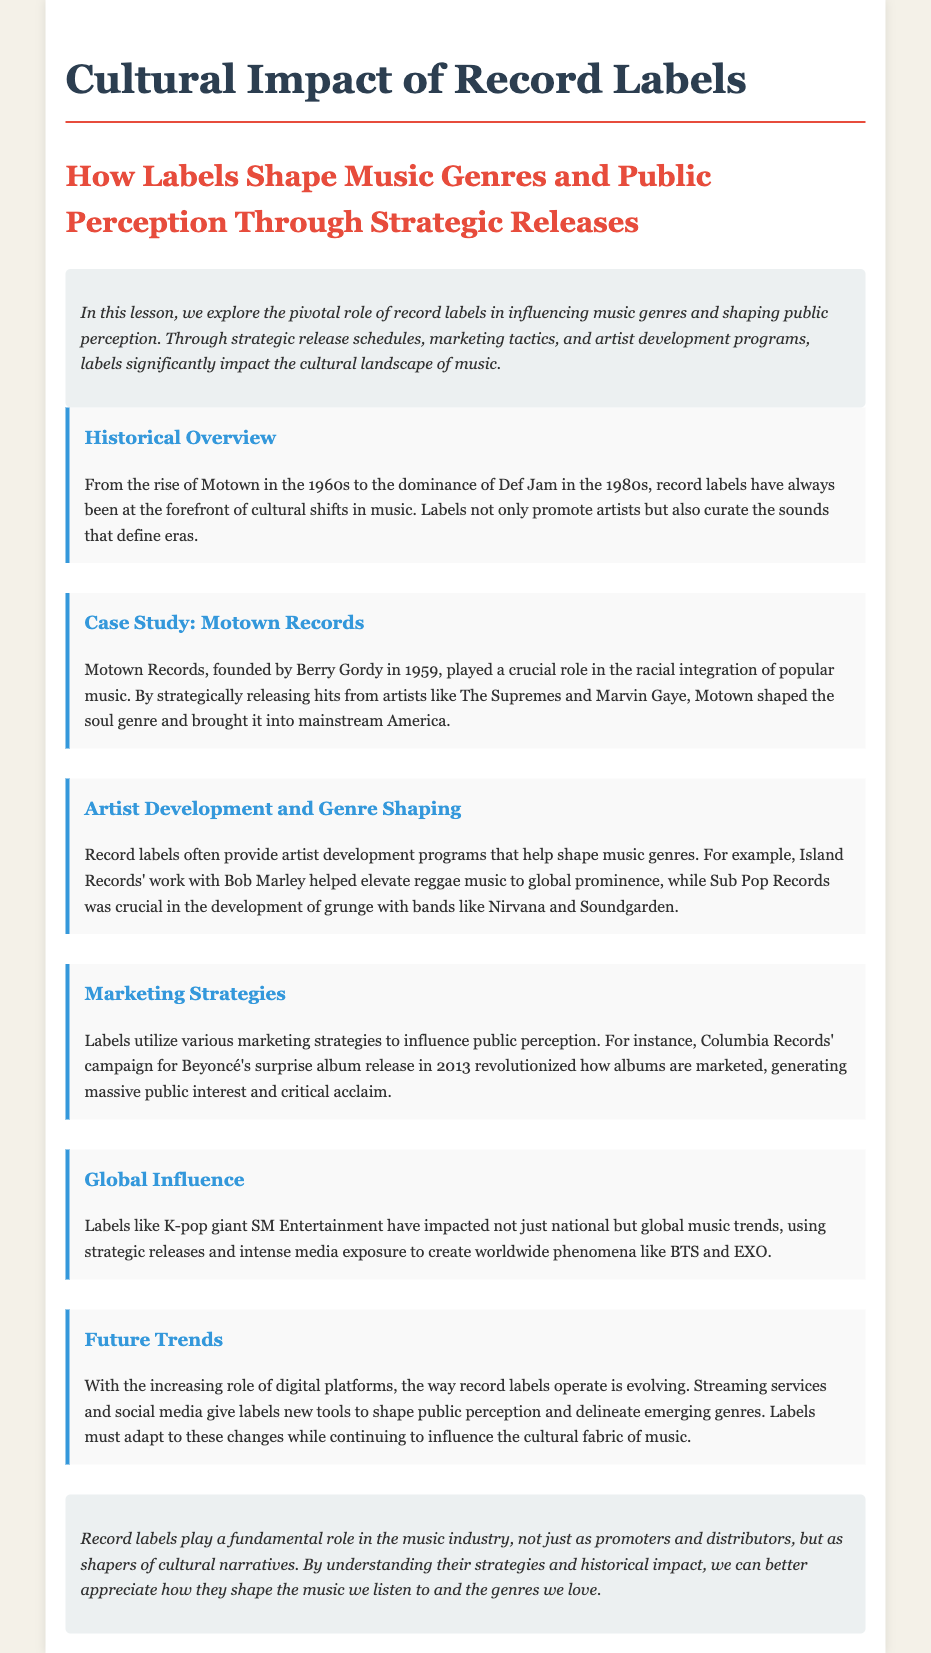What role did Motown Records play in the 1960s? Motown Records played a crucial role in the racial integration of popular music.
Answer: Racial integration Who founded Motown Records? Motown Records was founded by Berry Gordy in 1959.
Answer: Berry Gordy Which artist’s work elevated reggae music to global prominence? Bob Marley’s work elevated reggae music to global prominence.
Answer: Bob Marley What innovative marketing strategy did Columbia Records use for Beyoncé's album? Columbia Records used a surprise album release campaign.
Answer: Surprise album release What type of music was shaped by Sub Pop Records? Sub Pop Records was crucial in the development of grunge.
Answer: Grunge Which global K-pop label is mentioned in the document? SM Entertainment is the global K-pop label mentioned.
Answer: SM Entertainment What has changed about the operations of record labels in the digital era? The way record labels operate is evolving due to digital platforms.
Answer: Evolving What genre does the case study of Motown highlight? The case study of Motown highlights the soul genre.
Answer: Soul How does the lesson plan describe the role of record labels? Record labels are described as shapers of cultural narratives.
Answer: Shapers of cultural narratives 